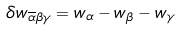<formula> <loc_0><loc_0><loc_500><loc_500>\delta w _ { \overline { \alpha } \beta \gamma } = w _ { \alpha } - w _ { \beta } - w _ { \gamma }</formula> 